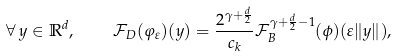<formula> <loc_0><loc_0><loc_500><loc_500>\forall \, y \in \mathbb { R } ^ { d } , \quad \mathcal { F } _ { D } ( \varphi _ { \varepsilon } ) ( y ) = \frac { 2 ^ { \gamma + \frac { d } { 2 } } } { c _ { k } } \mathcal { F } _ { B } ^ { \gamma + \frac { d } { 2 } - 1 } ( \phi ) ( \varepsilon \| y \| ) ,</formula> 